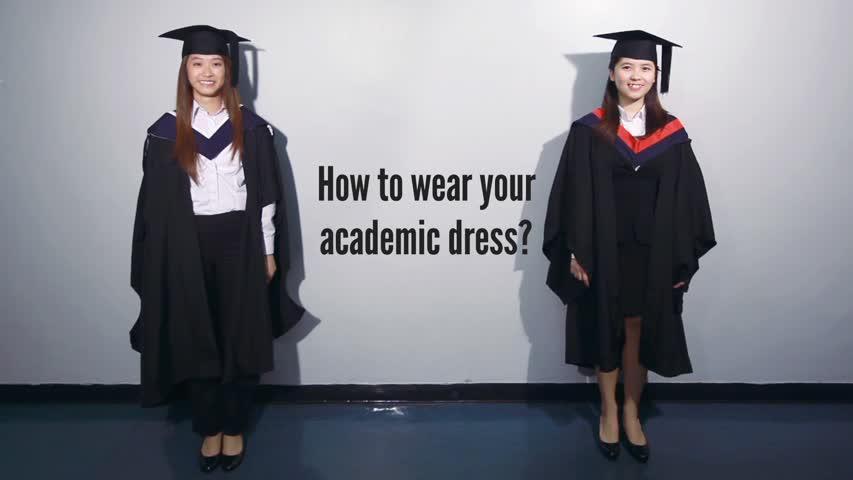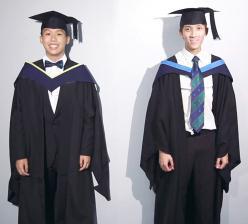The first image is the image on the left, the second image is the image on the right. Examine the images to the left and right. Is the description "The same number of graduates are shown in the left and right images." accurate? Answer yes or no. Yes. 